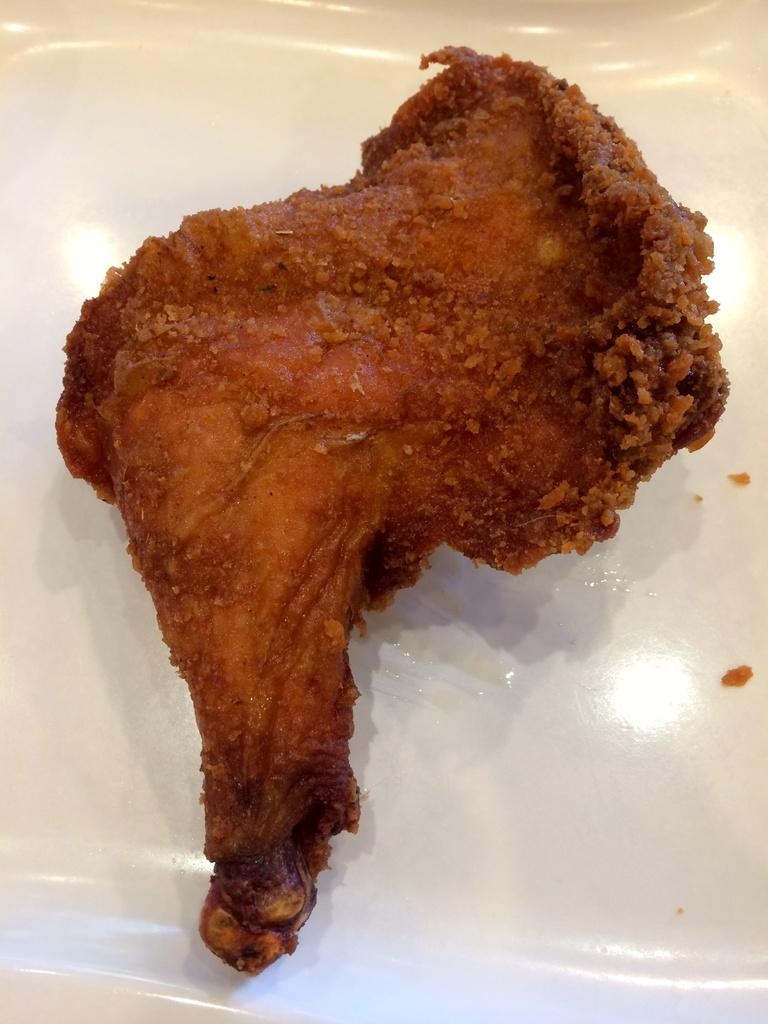What color is the plate in the image? The plate in the image is white. What is on the plate in the image? There is chicken peace on the plate. How long does it take for the creator to finish the chicken peace in the image? The image does not provide information about the creator or the time it takes to finish the chicken peace, so this question cannot be answered definitively. 